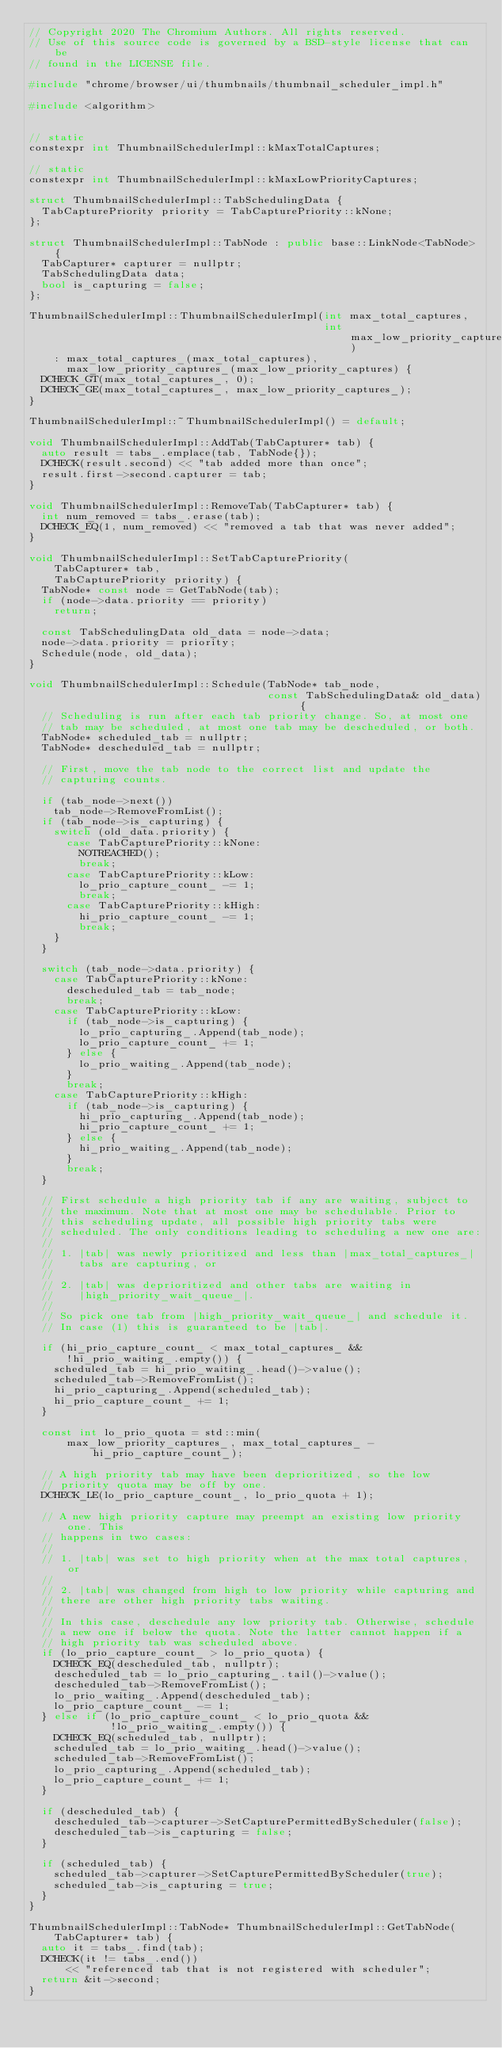<code> <loc_0><loc_0><loc_500><loc_500><_C++_>// Copyright 2020 The Chromium Authors. All rights reserved.
// Use of this source code is governed by a BSD-style license that can be
// found in the LICENSE file.

#include "chrome/browser/ui/thumbnails/thumbnail_scheduler_impl.h"

#include <algorithm>


// static
constexpr int ThumbnailSchedulerImpl::kMaxTotalCaptures;

// static
constexpr int ThumbnailSchedulerImpl::kMaxLowPriorityCaptures;

struct ThumbnailSchedulerImpl::TabSchedulingData {
  TabCapturePriority priority = TabCapturePriority::kNone;
};

struct ThumbnailSchedulerImpl::TabNode : public base::LinkNode<TabNode> {
  TabCapturer* capturer = nullptr;
  TabSchedulingData data;
  bool is_capturing = false;
};

ThumbnailSchedulerImpl::ThumbnailSchedulerImpl(int max_total_captures,
                                               int max_low_priority_captures)
    : max_total_captures_(max_total_captures),
      max_low_priority_captures_(max_low_priority_captures) {
  DCHECK_GT(max_total_captures_, 0);
  DCHECK_GE(max_total_captures_, max_low_priority_captures_);
}

ThumbnailSchedulerImpl::~ThumbnailSchedulerImpl() = default;

void ThumbnailSchedulerImpl::AddTab(TabCapturer* tab) {
  auto result = tabs_.emplace(tab, TabNode{});
  DCHECK(result.second) << "tab added more than once";
  result.first->second.capturer = tab;
}

void ThumbnailSchedulerImpl::RemoveTab(TabCapturer* tab) {
  int num_removed = tabs_.erase(tab);
  DCHECK_EQ(1, num_removed) << "removed a tab that was never added";
}

void ThumbnailSchedulerImpl::SetTabCapturePriority(
    TabCapturer* tab,
    TabCapturePriority priority) {
  TabNode* const node = GetTabNode(tab);
  if (node->data.priority == priority)
    return;

  const TabSchedulingData old_data = node->data;
  node->data.priority = priority;
  Schedule(node, old_data);
}

void ThumbnailSchedulerImpl::Schedule(TabNode* tab_node,
                                      const TabSchedulingData& old_data) {
  // Scheduling is run after each tab priority change. So, at most one
  // tab may be scheduled, at most one tab may be descheduled, or both.
  TabNode* scheduled_tab = nullptr;
  TabNode* descheduled_tab = nullptr;

  // First, move the tab node to the correct list and update the
  // capturing counts.

  if (tab_node->next())
    tab_node->RemoveFromList();
  if (tab_node->is_capturing) {
    switch (old_data.priority) {
      case TabCapturePriority::kNone:
        NOTREACHED();
        break;
      case TabCapturePriority::kLow:
        lo_prio_capture_count_ -= 1;
        break;
      case TabCapturePriority::kHigh:
        hi_prio_capture_count_ -= 1;
        break;
    }
  }

  switch (tab_node->data.priority) {
    case TabCapturePriority::kNone:
      descheduled_tab = tab_node;
      break;
    case TabCapturePriority::kLow:
      if (tab_node->is_capturing) {
        lo_prio_capturing_.Append(tab_node);
        lo_prio_capture_count_ += 1;
      } else {
        lo_prio_waiting_.Append(tab_node);
      }
      break;
    case TabCapturePriority::kHigh:
      if (tab_node->is_capturing) {
        hi_prio_capturing_.Append(tab_node);
        hi_prio_capture_count_ += 1;
      } else {
        hi_prio_waiting_.Append(tab_node);
      }
      break;
  }

  // First schedule a high priority tab if any are waiting, subject to
  // the maximum. Note that at most one may be schedulable. Prior to
  // this scheduling update, all possible high priority tabs were
  // scheduled. The only conditions leading to scheduling a new one are:
  //
  // 1. |tab| was newly prioritized and less than |max_total_captures_|
  //    tabs are capturing, or
  //
  // 2. |tab| was deprioritized and other tabs are waiting in
  //    |high_priority_wait_queue_|.
  //
  // So pick one tab from |high_priority_wait_queue_| and schedule it.
  // In case (1) this is guaranteed to be |tab|.

  if (hi_prio_capture_count_ < max_total_captures_ &&
      !hi_prio_waiting_.empty()) {
    scheduled_tab = hi_prio_waiting_.head()->value();
    scheduled_tab->RemoveFromList();
    hi_prio_capturing_.Append(scheduled_tab);
    hi_prio_capture_count_ += 1;
  }

  const int lo_prio_quota = std::min(
      max_low_priority_captures_, max_total_captures_ - hi_prio_capture_count_);

  // A high priority tab may have been deprioritized, so the low
  // priority quota may be off by one.
  DCHECK_LE(lo_prio_capture_count_, lo_prio_quota + 1);

  // A new high priority capture may preempt an existing low priority one. This
  // happens in two cases:
  //
  // 1. |tab| was set to high priority when at the max total captures, or
  //
  // 2. |tab| was changed from high to low priority while capturing and
  // there are other high priority tabs waiting.
  //
  // In this case, deschedule any low priority tab. Otherwise, schedule
  // a new one if below the quota. Note the latter cannot happen if a
  // high priority tab was scheduled above.
  if (lo_prio_capture_count_ > lo_prio_quota) {
    DCHECK_EQ(descheduled_tab, nullptr);
    descheduled_tab = lo_prio_capturing_.tail()->value();
    descheduled_tab->RemoveFromList();
    lo_prio_waiting_.Append(descheduled_tab);
    lo_prio_capture_count_ -= 1;
  } else if (lo_prio_capture_count_ < lo_prio_quota &&
             !lo_prio_waiting_.empty()) {
    DCHECK_EQ(scheduled_tab, nullptr);
    scheduled_tab = lo_prio_waiting_.head()->value();
    scheduled_tab->RemoveFromList();
    lo_prio_capturing_.Append(scheduled_tab);
    lo_prio_capture_count_ += 1;
  }

  if (descheduled_tab) {
    descheduled_tab->capturer->SetCapturePermittedByScheduler(false);
    descheduled_tab->is_capturing = false;
  }

  if (scheduled_tab) {
    scheduled_tab->capturer->SetCapturePermittedByScheduler(true);
    scheduled_tab->is_capturing = true;
  }
}

ThumbnailSchedulerImpl::TabNode* ThumbnailSchedulerImpl::GetTabNode(
    TabCapturer* tab) {
  auto it = tabs_.find(tab);
  DCHECK(it != tabs_.end())
      << "referenced tab that is not registered with scheduler";
  return &it->second;
}
</code> 